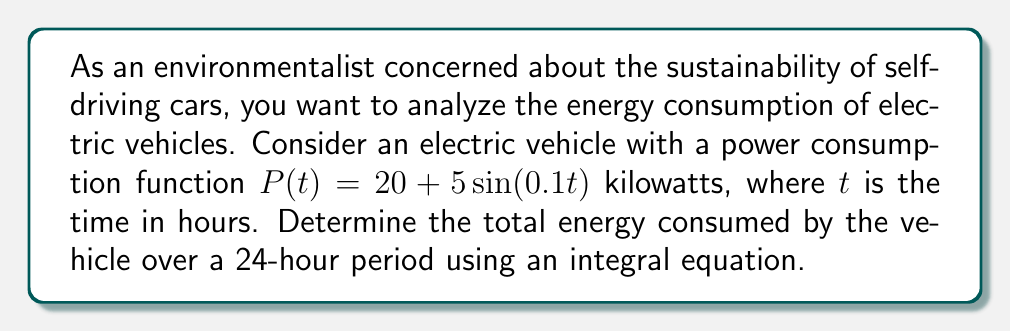Provide a solution to this math problem. To solve this problem, we'll follow these steps:

1) The energy consumed is the integral of power over time. We need to set up the integral equation:

   $$E = \int_0^{24} P(t) dt$$

   where $E$ is the total energy consumed in kilowatt-hours (kWh).

2) Substitute the given power function into the integral:

   $$E = \int_0^{24} (20 + 5\sin(0.1t)) dt$$

3) Split the integral:

   $$E = \int_0^{24} 20 dt + \int_0^{24} 5\sin(0.1t) dt$$

4) Solve the first part of the integral:

   $$\int_0^{24} 20 dt = 20t \bigg|_0^{24} = 20 \cdot 24 - 20 \cdot 0 = 480$$

5) Solve the second part of the integral:

   $$\int_0^{24} 5\sin(0.1t) dt = -50\cos(0.1t) \bigg|_0^{24}$$
   $$= -50(\cos(2.4) - \cos(0)) = -50(\cos(2.4) - 1)$$

6) Combine the results:

   $$E = 480 - 50(\cos(2.4) - 1)$$

7) Calculate the final value:

   $$E \approx 480 - 50(-0.7373 - 1) = 480 + 86.865 = 566.865$$

Thus, the total energy consumed over 24 hours is approximately 566.865 kWh.
Answer: 566.865 kWh 